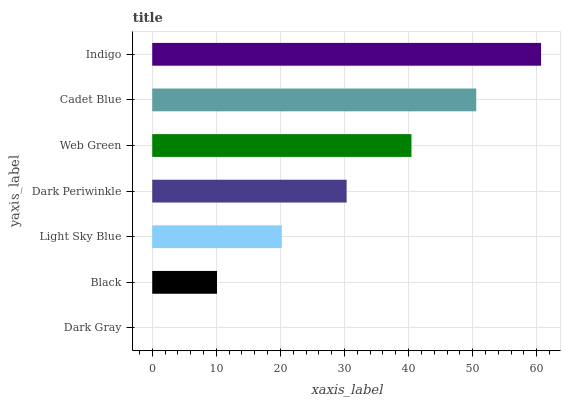Is Dark Gray the minimum?
Answer yes or no. Yes. Is Indigo the maximum?
Answer yes or no. Yes. Is Black the minimum?
Answer yes or no. No. Is Black the maximum?
Answer yes or no. No. Is Black greater than Dark Gray?
Answer yes or no. Yes. Is Dark Gray less than Black?
Answer yes or no. Yes. Is Dark Gray greater than Black?
Answer yes or no. No. Is Black less than Dark Gray?
Answer yes or no. No. Is Dark Periwinkle the high median?
Answer yes or no. Yes. Is Dark Periwinkle the low median?
Answer yes or no. Yes. Is Dark Gray the high median?
Answer yes or no. No. Is Dark Gray the low median?
Answer yes or no. No. 